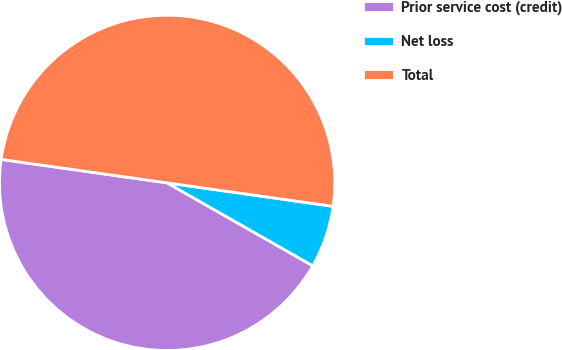Convert chart. <chart><loc_0><loc_0><loc_500><loc_500><pie_chart><fcel>Prior service cost (credit)<fcel>Net loss<fcel>Total<nl><fcel>44.0%<fcel>6.0%<fcel>50.0%<nl></chart> 